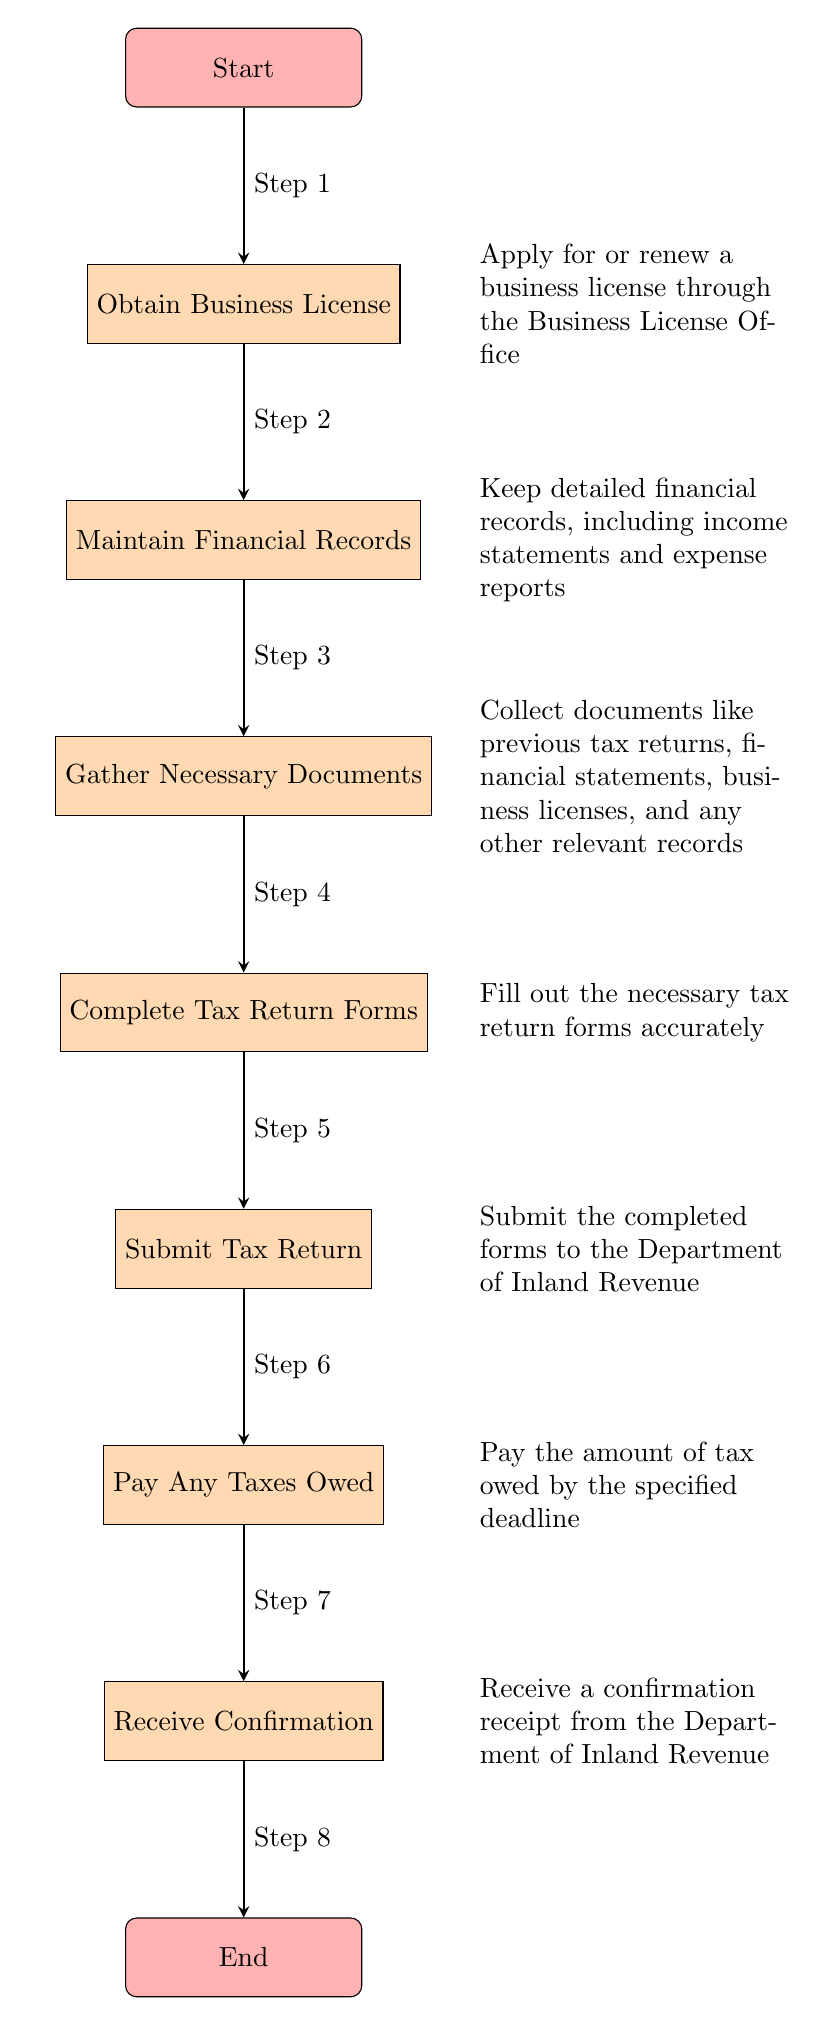What is the first step in the tax return filing process? The diagram shows that the first step is to "Obtain Business License," which is located directly below the "Start" node.
Answer: Obtain Business License How many steps are there in total to complete the tax return filing? By counting the nodes representing process steps from "Start" to "End," there are a total of 8 steps indicated in the flowchart.
Answer: 8 What must be completed before submitting the tax return? The diagram indicates that the tax return forms must be completed before the submission, as it is the direct predecessor node to "Submit Tax Return."
Answer: Complete Tax Return Forms Which step involves making a payment? The step labeled "Pay Any Taxes Owed," is directly below the "Submit Tax Return" step, indicating that it involves making a payment after submission.
Answer: Pay Any Taxes Owed What do you receive after confirming the submission of the tax return? The last step preceding "End" is labeled "Receive Confirmation," which shows that a confirmation receipt is what you receive after submission.
Answer: Receive Confirmation What type of records must be maintained before tax return filing? The arrow leading from "Obtain Business License" to "Maintain Financial Records" indicates that detailed financial records should be kept, including income statements and expense reports.
Answer: Maintain Financial Records What is the relationship between "Gather Necessary Documents" and "Complete Tax Return Forms"? "Gather Necessary Documents" is the step that must be completed before "Complete Tax Return Forms," as indicated by the directional flow from one to the other.
Answer: Sequential Which document is required to start the process? The process starts with obtaining a "Business License," which is the first document referred to in the diagram.
Answer: Business License What is the last action taken in the tax return filing process? The diagram outlines that the last action taken is to "Receive Confirmation," marking the completion of the process right before reaching the "End."
Answer: Receive Confirmation 